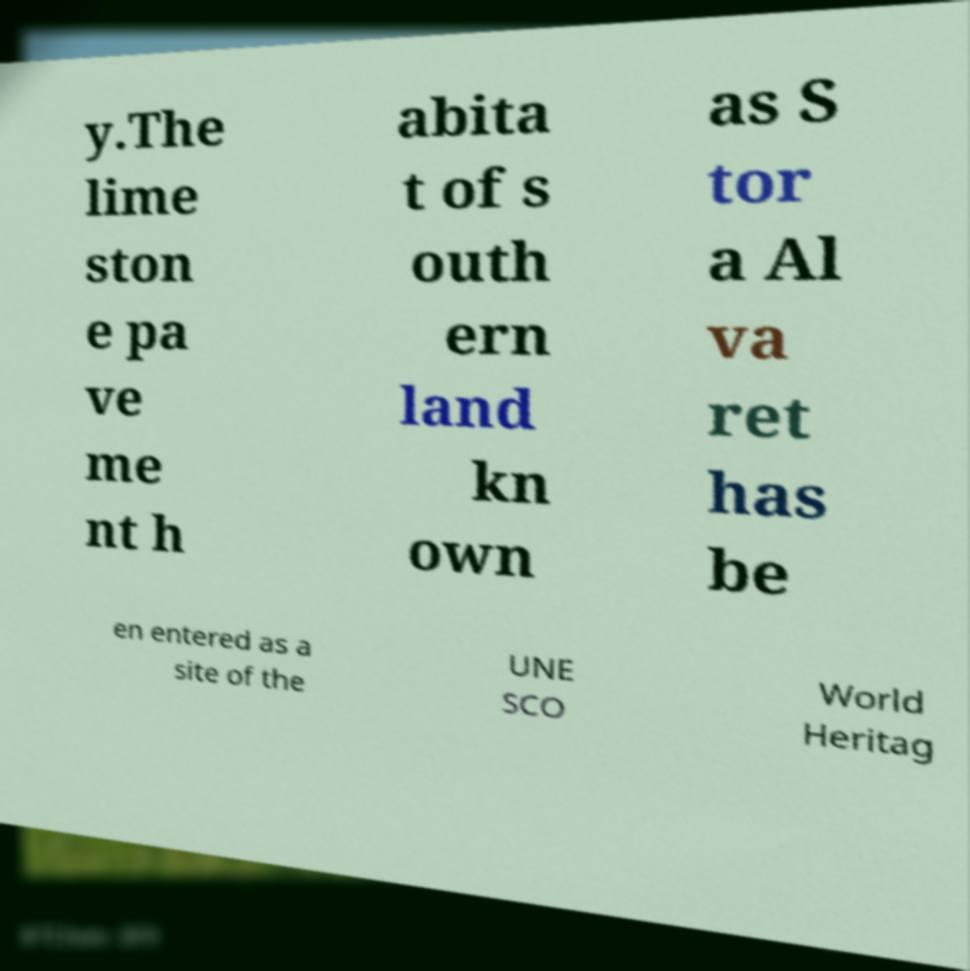Could you assist in decoding the text presented in this image and type it out clearly? y.The lime ston e pa ve me nt h abita t of s outh ern land kn own as S tor a Al va ret has be en entered as a site of the UNE SCO World Heritag 